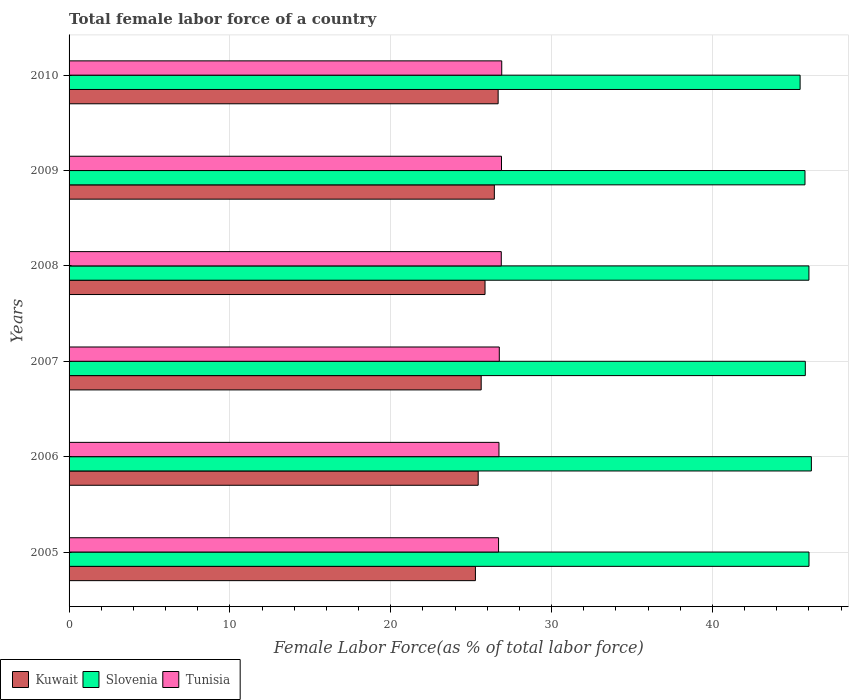How many different coloured bars are there?
Make the answer very short. 3. How many groups of bars are there?
Your answer should be very brief. 6. Are the number of bars per tick equal to the number of legend labels?
Give a very brief answer. Yes. What is the label of the 1st group of bars from the top?
Ensure brevity in your answer.  2010. In how many cases, is the number of bars for a given year not equal to the number of legend labels?
Provide a short and direct response. 0. What is the percentage of female labor force in Kuwait in 2005?
Offer a terse response. 25.27. Across all years, what is the maximum percentage of female labor force in Tunisia?
Keep it short and to the point. 26.9. Across all years, what is the minimum percentage of female labor force in Kuwait?
Your response must be concise. 25.27. In which year was the percentage of female labor force in Slovenia maximum?
Provide a short and direct response. 2006. In which year was the percentage of female labor force in Tunisia minimum?
Offer a terse response. 2005. What is the total percentage of female labor force in Tunisia in the graph?
Provide a succinct answer. 160.86. What is the difference between the percentage of female labor force in Slovenia in 2006 and that in 2010?
Your answer should be very brief. 0.7. What is the difference between the percentage of female labor force in Kuwait in 2006 and the percentage of female labor force in Slovenia in 2007?
Provide a short and direct response. -20.34. What is the average percentage of female labor force in Slovenia per year?
Give a very brief answer. 45.86. In the year 2008, what is the difference between the percentage of female labor force in Tunisia and percentage of female labor force in Slovenia?
Make the answer very short. -19.13. In how many years, is the percentage of female labor force in Tunisia greater than 46 %?
Offer a terse response. 0. What is the ratio of the percentage of female labor force in Tunisia in 2008 to that in 2009?
Give a very brief answer. 1. What is the difference between the highest and the second highest percentage of female labor force in Tunisia?
Offer a terse response. 0.01. What is the difference between the highest and the lowest percentage of female labor force in Tunisia?
Provide a short and direct response. 0.2. What does the 1st bar from the top in 2010 represents?
Ensure brevity in your answer.  Tunisia. What does the 1st bar from the bottom in 2007 represents?
Your answer should be compact. Kuwait. Are all the bars in the graph horizontal?
Make the answer very short. Yes. Does the graph contain grids?
Your answer should be very brief. Yes. Where does the legend appear in the graph?
Keep it short and to the point. Bottom left. How are the legend labels stacked?
Give a very brief answer. Horizontal. What is the title of the graph?
Offer a terse response. Total female labor force of a country. Does "Low & middle income" appear as one of the legend labels in the graph?
Ensure brevity in your answer.  No. What is the label or title of the X-axis?
Offer a very short reply. Female Labor Force(as % of total labor force). What is the Female Labor Force(as % of total labor force) in Kuwait in 2005?
Ensure brevity in your answer.  25.27. What is the Female Labor Force(as % of total labor force) in Slovenia in 2005?
Ensure brevity in your answer.  46.01. What is the Female Labor Force(as % of total labor force) of Tunisia in 2005?
Provide a succinct answer. 26.71. What is the Female Labor Force(as % of total labor force) in Kuwait in 2006?
Give a very brief answer. 25.44. What is the Female Labor Force(as % of total labor force) in Slovenia in 2006?
Offer a very short reply. 46.16. What is the Female Labor Force(as % of total labor force) in Tunisia in 2006?
Provide a succinct answer. 26.73. What is the Female Labor Force(as % of total labor force) in Kuwait in 2007?
Your answer should be compact. 25.63. What is the Female Labor Force(as % of total labor force) in Slovenia in 2007?
Make the answer very short. 45.78. What is the Female Labor Force(as % of total labor force) in Tunisia in 2007?
Your answer should be compact. 26.75. What is the Female Labor Force(as % of total labor force) of Kuwait in 2008?
Your answer should be very brief. 25.86. What is the Female Labor Force(as % of total labor force) of Slovenia in 2008?
Keep it short and to the point. 46.01. What is the Female Labor Force(as % of total labor force) in Tunisia in 2008?
Your answer should be compact. 26.88. What is the Female Labor Force(as % of total labor force) of Kuwait in 2009?
Offer a very short reply. 26.44. What is the Female Labor Force(as % of total labor force) of Slovenia in 2009?
Your answer should be very brief. 45.76. What is the Female Labor Force(as % of total labor force) in Tunisia in 2009?
Give a very brief answer. 26.89. What is the Female Labor Force(as % of total labor force) of Kuwait in 2010?
Offer a very short reply. 26.68. What is the Female Labor Force(as % of total labor force) in Slovenia in 2010?
Offer a terse response. 45.46. What is the Female Labor Force(as % of total labor force) in Tunisia in 2010?
Provide a short and direct response. 26.9. Across all years, what is the maximum Female Labor Force(as % of total labor force) of Kuwait?
Your response must be concise. 26.68. Across all years, what is the maximum Female Labor Force(as % of total labor force) in Slovenia?
Keep it short and to the point. 46.16. Across all years, what is the maximum Female Labor Force(as % of total labor force) in Tunisia?
Provide a succinct answer. 26.9. Across all years, what is the minimum Female Labor Force(as % of total labor force) of Kuwait?
Keep it short and to the point. 25.27. Across all years, what is the minimum Female Labor Force(as % of total labor force) of Slovenia?
Provide a succinct answer. 45.46. Across all years, what is the minimum Female Labor Force(as % of total labor force) of Tunisia?
Your response must be concise. 26.71. What is the total Female Labor Force(as % of total labor force) of Kuwait in the graph?
Offer a very short reply. 155.32. What is the total Female Labor Force(as % of total labor force) in Slovenia in the graph?
Your response must be concise. 275.17. What is the total Female Labor Force(as % of total labor force) in Tunisia in the graph?
Provide a short and direct response. 160.86. What is the difference between the Female Labor Force(as % of total labor force) of Kuwait in 2005 and that in 2006?
Offer a terse response. -0.17. What is the difference between the Female Labor Force(as % of total labor force) in Slovenia in 2005 and that in 2006?
Offer a very short reply. -0.15. What is the difference between the Female Labor Force(as % of total labor force) of Tunisia in 2005 and that in 2006?
Offer a terse response. -0.03. What is the difference between the Female Labor Force(as % of total labor force) in Kuwait in 2005 and that in 2007?
Offer a terse response. -0.36. What is the difference between the Female Labor Force(as % of total labor force) of Slovenia in 2005 and that in 2007?
Your answer should be compact. 0.23. What is the difference between the Female Labor Force(as % of total labor force) in Tunisia in 2005 and that in 2007?
Offer a very short reply. -0.05. What is the difference between the Female Labor Force(as % of total labor force) of Kuwait in 2005 and that in 2008?
Provide a succinct answer. -0.6. What is the difference between the Female Labor Force(as % of total labor force) of Slovenia in 2005 and that in 2008?
Make the answer very short. 0. What is the difference between the Female Labor Force(as % of total labor force) of Tunisia in 2005 and that in 2008?
Ensure brevity in your answer.  -0.17. What is the difference between the Female Labor Force(as % of total labor force) in Kuwait in 2005 and that in 2009?
Keep it short and to the point. -1.18. What is the difference between the Female Labor Force(as % of total labor force) of Slovenia in 2005 and that in 2009?
Offer a very short reply. 0.25. What is the difference between the Female Labor Force(as % of total labor force) in Tunisia in 2005 and that in 2009?
Provide a short and direct response. -0.18. What is the difference between the Female Labor Force(as % of total labor force) in Kuwait in 2005 and that in 2010?
Provide a short and direct response. -1.41. What is the difference between the Female Labor Force(as % of total labor force) of Slovenia in 2005 and that in 2010?
Provide a short and direct response. 0.55. What is the difference between the Female Labor Force(as % of total labor force) of Tunisia in 2005 and that in 2010?
Your answer should be very brief. -0.2. What is the difference between the Female Labor Force(as % of total labor force) in Kuwait in 2006 and that in 2007?
Provide a succinct answer. -0.19. What is the difference between the Female Labor Force(as % of total labor force) in Slovenia in 2006 and that in 2007?
Offer a very short reply. 0.38. What is the difference between the Female Labor Force(as % of total labor force) of Tunisia in 2006 and that in 2007?
Your answer should be compact. -0.02. What is the difference between the Female Labor Force(as % of total labor force) in Kuwait in 2006 and that in 2008?
Your answer should be compact. -0.42. What is the difference between the Female Labor Force(as % of total labor force) in Slovenia in 2006 and that in 2008?
Your response must be concise. 0.15. What is the difference between the Female Labor Force(as % of total labor force) of Tunisia in 2006 and that in 2008?
Ensure brevity in your answer.  -0.14. What is the difference between the Female Labor Force(as % of total labor force) in Kuwait in 2006 and that in 2009?
Provide a short and direct response. -1. What is the difference between the Female Labor Force(as % of total labor force) in Slovenia in 2006 and that in 2009?
Give a very brief answer. 0.4. What is the difference between the Female Labor Force(as % of total labor force) of Tunisia in 2006 and that in 2009?
Make the answer very short. -0.16. What is the difference between the Female Labor Force(as % of total labor force) of Kuwait in 2006 and that in 2010?
Make the answer very short. -1.24. What is the difference between the Female Labor Force(as % of total labor force) in Slovenia in 2006 and that in 2010?
Provide a short and direct response. 0.7. What is the difference between the Female Labor Force(as % of total labor force) in Tunisia in 2006 and that in 2010?
Offer a terse response. -0.17. What is the difference between the Female Labor Force(as % of total labor force) of Kuwait in 2007 and that in 2008?
Give a very brief answer. -0.24. What is the difference between the Female Labor Force(as % of total labor force) of Slovenia in 2007 and that in 2008?
Offer a terse response. -0.22. What is the difference between the Female Labor Force(as % of total labor force) in Tunisia in 2007 and that in 2008?
Provide a succinct answer. -0.12. What is the difference between the Female Labor Force(as % of total labor force) of Kuwait in 2007 and that in 2009?
Your answer should be compact. -0.82. What is the difference between the Female Labor Force(as % of total labor force) in Tunisia in 2007 and that in 2009?
Provide a succinct answer. -0.14. What is the difference between the Female Labor Force(as % of total labor force) of Kuwait in 2007 and that in 2010?
Give a very brief answer. -1.05. What is the difference between the Female Labor Force(as % of total labor force) in Slovenia in 2007 and that in 2010?
Provide a short and direct response. 0.32. What is the difference between the Female Labor Force(as % of total labor force) of Tunisia in 2007 and that in 2010?
Make the answer very short. -0.15. What is the difference between the Female Labor Force(as % of total labor force) in Kuwait in 2008 and that in 2009?
Your answer should be very brief. -0.58. What is the difference between the Female Labor Force(as % of total labor force) in Slovenia in 2008 and that in 2009?
Give a very brief answer. 0.24. What is the difference between the Female Labor Force(as % of total labor force) in Tunisia in 2008 and that in 2009?
Keep it short and to the point. -0.01. What is the difference between the Female Labor Force(as % of total labor force) of Kuwait in 2008 and that in 2010?
Make the answer very short. -0.82. What is the difference between the Female Labor Force(as % of total labor force) of Slovenia in 2008 and that in 2010?
Your response must be concise. 0.55. What is the difference between the Female Labor Force(as % of total labor force) in Tunisia in 2008 and that in 2010?
Offer a terse response. -0.03. What is the difference between the Female Labor Force(as % of total labor force) of Kuwait in 2009 and that in 2010?
Ensure brevity in your answer.  -0.24. What is the difference between the Female Labor Force(as % of total labor force) of Slovenia in 2009 and that in 2010?
Make the answer very short. 0.3. What is the difference between the Female Labor Force(as % of total labor force) of Tunisia in 2009 and that in 2010?
Your answer should be compact. -0.01. What is the difference between the Female Labor Force(as % of total labor force) of Kuwait in 2005 and the Female Labor Force(as % of total labor force) of Slovenia in 2006?
Provide a short and direct response. -20.89. What is the difference between the Female Labor Force(as % of total labor force) in Kuwait in 2005 and the Female Labor Force(as % of total labor force) in Tunisia in 2006?
Your response must be concise. -1.46. What is the difference between the Female Labor Force(as % of total labor force) in Slovenia in 2005 and the Female Labor Force(as % of total labor force) in Tunisia in 2006?
Your answer should be compact. 19.28. What is the difference between the Female Labor Force(as % of total labor force) of Kuwait in 2005 and the Female Labor Force(as % of total labor force) of Slovenia in 2007?
Your response must be concise. -20.51. What is the difference between the Female Labor Force(as % of total labor force) of Kuwait in 2005 and the Female Labor Force(as % of total labor force) of Tunisia in 2007?
Ensure brevity in your answer.  -1.48. What is the difference between the Female Labor Force(as % of total labor force) in Slovenia in 2005 and the Female Labor Force(as % of total labor force) in Tunisia in 2007?
Your response must be concise. 19.26. What is the difference between the Female Labor Force(as % of total labor force) of Kuwait in 2005 and the Female Labor Force(as % of total labor force) of Slovenia in 2008?
Your response must be concise. -20.74. What is the difference between the Female Labor Force(as % of total labor force) of Kuwait in 2005 and the Female Labor Force(as % of total labor force) of Tunisia in 2008?
Keep it short and to the point. -1.61. What is the difference between the Female Labor Force(as % of total labor force) of Slovenia in 2005 and the Female Labor Force(as % of total labor force) of Tunisia in 2008?
Your answer should be very brief. 19.13. What is the difference between the Female Labor Force(as % of total labor force) in Kuwait in 2005 and the Female Labor Force(as % of total labor force) in Slovenia in 2009?
Give a very brief answer. -20.49. What is the difference between the Female Labor Force(as % of total labor force) in Kuwait in 2005 and the Female Labor Force(as % of total labor force) in Tunisia in 2009?
Offer a terse response. -1.62. What is the difference between the Female Labor Force(as % of total labor force) in Slovenia in 2005 and the Female Labor Force(as % of total labor force) in Tunisia in 2009?
Provide a succinct answer. 19.12. What is the difference between the Female Labor Force(as % of total labor force) in Kuwait in 2005 and the Female Labor Force(as % of total labor force) in Slovenia in 2010?
Your answer should be compact. -20.19. What is the difference between the Female Labor Force(as % of total labor force) of Kuwait in 2005 and the Female Labor Force(as % of total labor force) of Tunisia in 2010?
Ensure brevity in your answer.  -1.64. What is the difference between the Female Labor Force(as % of total labor force) of Slovenia in 2005 and the Female Labor Force(as % of total labor force) of Tunisia in 2010?
Ensure brevity in your answer.  19.11. What is the difference between the Female Labor Force(as % of total labor force) in Kuwait in 2006 and the Female Labor Force(as % of total labor force) in Slovenia in 2007?
Offer a very short reply. -20.34. What is the difference between the Female Labor Force(as % of total labor force) of Kuwait in 2006 and the Female Labor Force(as % of total labor force) of Tunisia in 2007?
Keep it short and to the point. -1.31. What is the difference between the Female Labor Force(as % of total labor force) of Slovenia in 2006 and the Female Labor Force(as % of total labor force) of Tunisia in 2007?
Provide a short and direct response. 19.41. What is the difference between the Female Labor Force(as % of total labor force) of Kuwait in 2006 and the Female Labor Force(as % of total labor force) of Slovenia in 2008?
Keep it short and to the point. -20.57. What is the difference between the Female Labor Force(as % of total labor force) in Kuwait in 2006 and the Female Labor Force(as % of total labor force) in Tunisia in 2008?
Make the answer very short. -1.44. What is the difference between the Female Labor Force(as % of total labor force) of Slovenia in 2006 and the Female Labor Force(as % of total labor force) of Tunisia in 2008?
Provide a succinct answer. 19.28. What is the difference between the Female Labor Force(as % of total labor force) of Kuwait in 2006 and the Female Labor Force(as % of total labor force) of Slovenia in 2009?
Ensure brevity in your answer.  -20.32. What is the difference between the Female Labor Force(as % of total labor force) in Kuwait in 2006 and the Female Labor Force(as % of total labor force) in Tunisia in 2009?
Give a very brief answer. -1.45. What is the difference between the Female Labor Force(as % of total labor force) of Slovenia in 2006 and the Female Labor Force(as % of total labor force) of Tunisia in 2009?
Keep it short and to the point. 19.27. What is the difference between the Female Labor Force(as % of total labor force) of Kuwait in 2006 and the Female Labor Force(as % of total labor force) of Slovenia in 2010?
Your response must be concise. -20.02. What is the difference between the Female Labor Force(as % of total labor force) in Kuwait in 2006 and the Female Labor Force(as % of total labor force) in Tunisia in 2010?
Offer a very short reply. -1.46. What is the difference between the Female Labor Force(as % of total labor force) in Slovenia in 2006 and the Female Labor Force(as % of total labor force) in Tunisia in 2010?
Ensure brevity in your answer.  19.25. What is the difference between the Female Labor Force(as % of total labor force) in Kuwait in 2007 and the Female Labor Force(as % of total labor force) in Slovenia in 2008?
Provide a succinct answer. -20.38. What is the difference between the Female Labor Force(as % of total labor force) in Kuwait in 2007 and the Female Labor Force(as % of total labor force) in Tunisia in 2008?
Provide a succinct answer. -1.25. What is the difference between the Female Labor Force(as % of total labor force) in Slovenia in 2007 and the Female Labor Force(as % of total labor force) in Tunisia in 2008?
Provide a short and direct response. 18.91. What is the difference between the Female Labor Force(as % of total labor force) in Kuwait in 2007 and the Female Labor Force(as % of total labor force) in Slovenia in 2009?
Ensure brevity in your answer.  -20.13. What is the difference between the Female Labor Force(as % of total labor force) of Kuwait in 2007 and the Female Labor Force(as % of total labor force) of Tunisia in 2009?
Offer a terse response. -1.26. What is the difference between the Female Labor Force(as % of total labor force) in Slovenia in 2007 and the Female Labor Force(as % of total labor force) in Tunisia in 2009?
Offer a terse response. 18.89. What is the difference between the Female Labor Force(as % of total labor force) in Kuwait in 2007 and the Female Labor Force(as % of total labor force) in Slovenia in 2010?
Keep it short and to the point. -19.83. What is the difference between the Female Labor Force(as % of total labor force) in Kuwait in 2007 and the Female Labor Force(as % of total labor force) in Tunisia in 2010?
Your answer should be compact. -1.28. What is the difference between the Female Labor Force(as % of total labor force) in Slovenia in 2007 and the Female Labor Force(as % of total labor force) in Tunisia in 2010?
Make the answer very short. 18.88. What is the difference between the Female Labor Force(as % of total labor force) of Kuwait in 2008 and the Female Labor Force(as % of total labor force) of Slovenia in 2009?
Your response must be concise. -19.9. What is the difference between the Female Labor Force(as % of total labor force) in Kuwait in 2008 and the Female Labor Force(as % of total labor force) in Tunisia in 2009?
Your answer should be very brief. -1.02. What is the difference between the Female Labor Force(as % of total labor force) of Slovenia in 2008 and the Female Labor Force(as % of total labor force) of Tunisia in 2009?
Offer a very short reply. 19.12. What is the difference between the Female Labor Force(as % of total labor force) of Kuwait in 2008 and the Female Labor Force(as % of total labor force) of Slovenia in 2010?
Your answer should be compact. -19.59. What is the difference between the Female Labor Force(as % of total labor force) in Kuwait in 2008 and the Female Labor Force(as % of total labor force) in Tunisia in 2010?
Keep it short and to the point. -1.04. What is the difference between the Female Labor Force(as % of total labor force) of Slovenia in 2008 and the Female Labor Force(as % of total labor force) of Tunisia in 2010?
Your answer should be compact. 19.1. What is the difference between the Female Labor Force(as % of total labor force) of Kuwait in 2009 and the Female Labor Force(as % of total labor force) of Slovenia in 2010?
Your response must be concise. -19.01. What is the difference between the Female Labor Force(as % of total labor force) of Kuwait in 2009 and the Female Labor Force(as % of total labor force) of Tunisia in 2010?
Offer a terse response. -0.46. What is the difference between the Female Labor Force(as % of total labor force) of Slovenia in 2009 and the Female Labor Force(as % of total labor force) of Tunisia in 2010?
Ensure brevity in your answer.  18.86. What is the average Female Labor Force(as % of total labor force) in Kuwait per year?
Provide a succinct answer. 25.89. What is the average Female Labor Force(as % of total labor force) of Slovenia per year?
Ensure brevity in your answer.  45.86. What is the average Female Labor Force(as % of total labor force) of Tunisia per year?
Give a very brief answer. 26.81. In the year 2005, what is the difference between the Female Labor Force(as % of total labor force) of Kuwait and Female Labor Force(as % of total labor force) of Slovenia?
Your response must be concise. -20.74. In the year 2005, what is the difference between the Female Labor Force(as % of total labor force) in Kuwait and Female Labor Force(as % of total labor force) in Tunisia?
Your answer should be compact. -1.44. In the year 2005, what is the difference between the Female Labor Force(as % of total labor force) of Slovenia and Female Labor Force(as % of total labor force) of Tunisia?
Provide a succinct answer. 19.3. In the year 2006, what is the difference between the Female Labor Force(as % of total labor force) in Kuwait and Female Labor Force(as % of total labor force) in Slovenia?
Your answer should be very brief. -20.72. In the year 2006, what is the difference between the Female Labor Force(as % of total labor force) of Kuwait and Female Labor Force(as % of total labor force) of Tunisia?
Your answer should be very brief. -1.29. In the year 2006, what is the difference between the Female Labor Force(as % of total labor force) of Slovenia and Female Labor Force(as % of total labor force) of Tunisia?
Give a very brief answer. 19.43. In the year 2007, what is the difference between the Female Labor Force(as % of total labor force) of Kuwait and Female Labor Force(as % of total labor force) of Slovenia?
Keep it short and to the point. -20.15. In the year 2007, what is the difference between the Female Labor Force(as % of total labor force) in Kuwait and Female Labor Force(as % of total labor force) in Tunisia?
Ensure brevity in your answer.  -1.13. In the year 2007, what is the difference between the Female Labor Force(as % of total labor force) in Slovenia and Female Labor Force(as % of total labor force) in Tunisia?
Ensure brevity in your answer.  19.03. In the year 2008, what is the difference between the Female Labor Force(as % of total labor force) of Kuwait and Female Labor Force(as % of total labor force) of Slovenia?
Offer a terse response. -20.14. In the year 2008, what is the difference between the Female Labor Force(as % of total labor force) of Kuwait and Female Labor Force(as % of total labor force) of Tunisia?
Offer a terse response. -1.01. In the year 2008, what is the difference between the Female Labor Force(as % of total labor force) of Slovenia and Female Labor Force(as % of total labor force) of Tunisia?
Offer a terse response. 19.13. In the year 2009, what is the difference between the Female Labor Force(as % of total labor force) in Kuwait and Female Labor Force(as % of total labor force) in Slovenia?
Your answer should be compact. -19.32. In the year 2009, what is the difference between the Female Labor Force(as % of total labor force) of Kuwait and Female Labor Force(as % of total labor force) of Tunisia?
Provide a succinct answer. -0.44. In the year 2009, what is the difference between the Female Labor Force(as % of total labor force) in Slovenia and Female Labor Force(as % of total labor force) in Tunisia?
Your answer should be very brief. 18.87. In the year 2010, what is the difference between the Female Labor Force(as % of total labor force) in Kuwait and Female Labor Force(as % of total labor force) in Slovenia?
Make the answer very short. -18.78. In the year 2010, what is the difference between the Female Labor Force(as % of total labor force) of Kuwait and Female Labor Force(as % of total labor force) of Tunisia?
Your response must be concise. -0.22. In the year 2010, what is the difference between the Female Labor Force(as % of total labor force) of Slovenia and Female Labor Force(as % of total labor force) of Tunisia?
Keep it short and to the point. 18.55. What is the ratio of the Female Labor Force(as % of total labor force) of Kuwait in 2005 to that in 2006?
Offer a very short reply. 0.99. What is the ratio of the Female Labor Force(as % of total labor force) in Tunisia in 2005 to that in 2006?
Your answer should be compact. 1. What is the ratio of the Female Labor Force(as % of total labor force) of Kuwait in 2005 to that in 2007?
Offer a very short reply. 0.99. What is the ratio of the Female Labor Force(as % of total labor force) of Tunisia in 2005 to that in 2007?
Ensure brevity in your answer.  1. What is the ratio of the Female Labor Force(as % of total labor force) in Kuwait in 2005 to that in 2008?
Keep it short and to the point. 0.98. What is the ratio of the Female Labor Force(as % of total labor force) of Slovenia in 2005 to that in 2008?
Provide a short and direct response. 1. What is the ratio of the Female Labor Force(as % of total labor force) of Kuwait in 2005 to that in 2009?
Provide a succinct answer. 0.96. What is the ratio of the Female Labor Force(as % of total labor force) of Slovenia in 2005 to that in 2009?
Your answer should be compact. 1.01. What is the ratio of the Female Labor Force(as % of total labor force) of Tunisia in 2005 to that in 2009?
Keep it short and to the point. 0.99. What is the ratio of the Female Labor Force(as % of total labor force) of Kuwait in 2005 to that in 2010?
Give a very brief answer. 0.95. What is the ratio of the Female Labor Force(as % of total labor force) of Slovenia in 2005 to that in 2010?
Keep it short and to the point. 1.01. What is the ratio of the Female Labor Force(as % of total labor force) in Tunisia in 2005 to that in 2010?
Give a very brief answer. 0.99. What is the ratio of the Female Labor Force(as % of total labor force) of Kuwait in 2006 to that in 2007?
Provide a short and direct response. 0.99. What is the ratio of the Female Labor Force(as % of total labor force) in Slovenia in 2006 to that in 2007?
Offer a terse response. 1.01. What is the ratio of the Female Labor Force(as % of total labor force) in Tunisia in 2006 to that in 2007?
Provide a short and direct response. 1. What is the ratio of the Female Labor Force(as % of total labor force) in Kuwait in 2006 to that in 2008?
Your answer should be compact. 0.98. What is the ratio of the Female Labor Force(as % of total labor force) of Slovenia in 2006 to that in 2008?
Make the answer very short. 1. What is the ratio of the Female Labor Force(as % of total labor force) of Tunisia in 2006 to that in 2008?
Offer a very short reply. 0.99. What is the ratio of the Female Labor Force(as % of total labor force) in Kuwait in 2006 to that in 2009?
Give a very brief answer. 0.96. What is the ratio of the Female Labor Force(as % of total labor force) of Slovenia in 2006 to that in 2009?
Give a very brief answer. 1.01. What is the ratio of the Female Labor Force(as % of total labor force) of Kuwait in 2006 to that in 2010?
Give a very brief answer. 0.95. What is the ratio of the Female Labor Force(as % of total labor force) in Slovenia in 2006 to that in 2010?
Offer a terse response. 1.02. What is the ratio of the Female Labor Force(as % of total labor force) in Tunisia in 2006 to that in 2010?
Provide a short and direct response. 0.99. What is the ratio of the Female Labor Force(as % of total labor force) of Kuwait in 2007 to that in 2008?
Provide a succinct answer. 0.99. What is the ratio of the Female Labor Force(as % of total labor force) in Slovenia in 2007 to that in 2008?
Offer a very short reply. 1. What is the ratio of the Female Labor Force(as % of total labor force) in Tunisia in 2007 to that in 2008?
Your answer should be compact. 1. What is the ratio of the Female Labor Force(as % of total labor force) in Kuwait in 2007 to that in 2009?
Your answer should be compact. 0.97. What is the ratio of the Female Labor Force(as % of total labor force) in Kuwait in 2007 to that in 2010?
Ensure brevity in your answer.  0.96. What is the ratio of the Female Labor Force(as % of total labor force) of Slovenia in 2007 to that in 2010?
Your answer should be very brief. 1.01. What is the ratio of the Female Labor Force(as % of total labor force) of Kuwait in 2008 to that in 2009?
Make the answer very short. 0.98. What is the ratio of the Female Labor Force(as % of total labor force) of Kuwait in 2008 to that in 2010?
Provide a short and direct response. 0.97. What is the ratio of the Female Labor Force(as % of total labor force) of Slovenia in 2008 to that in 2010?
Offer a very short reply. 1.01. What is the ratio of the Female Labor Force(as % of total labor force) in Tunisia in 2008 to that in 2010?
Your answer should be compact. 1. What is the ratio of the Female Labor Force(as % of total labor force) of Kuwait in 2009 to that in 2010?
Give a very brief answer. 0.99. What is the ratio of the Female Labor Force(as % of total labor force) in Slovenia in 2009 to that in 2010?
Your response must be concise. 1.01. What is the ratio of the Female Labor Force(as % of total labor force) in Tunisia in 2009 to that in 2010?
Keep it short and to the point. 1. What is the difference between the highest and the second highest Female Labor Force(as % of total labor force) in Kuwait?
Make the answer very short. 0.24. What is the difference between the highest and the second highest Female Labor Force(as % of total labor force) of Slovenia?
Offer a very short reply. 0.15. What is the difference between the highest and the second highest Female Labor Force(as % of total labor force) in Tunisia?
Your response must be concise. 0.01. What is the difference between the highest and the lowest Female Labor Force(as % of total labor force) in Kuwait?
Ensure brevity in your answer.  1.41. What is the difference between the highest and the lowest Female Labor Force(as % of total labor force) in Slovenia?
Your response must be concise. 0.7. What is the difference between the highest and the lowest Female Labor Force(as % of total labor force) in Tunisia?
Make the answer very short. 0.2. 